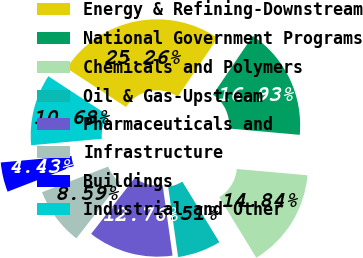<chart> <loc_0><loc_0><loc_500><loc_500><pie_chart><fcel>Energy & Refining-Downstream<fcel>National Government Programs<fcel>Chemicals and Polymers<fcel>Oil & Gas-Upstream<fcel>Pharmaceuticals and<fcel>Infrastructure<fcel>Buildings<fcel>Industrial and Other<nl><fcel>25.26%<fcel>16.93%<fcel>14.84%<fcel>6.51%<fcel>12.76%<fcel>8.59%<fcel>4.43%<fcel>10.68%<nl></chart> 